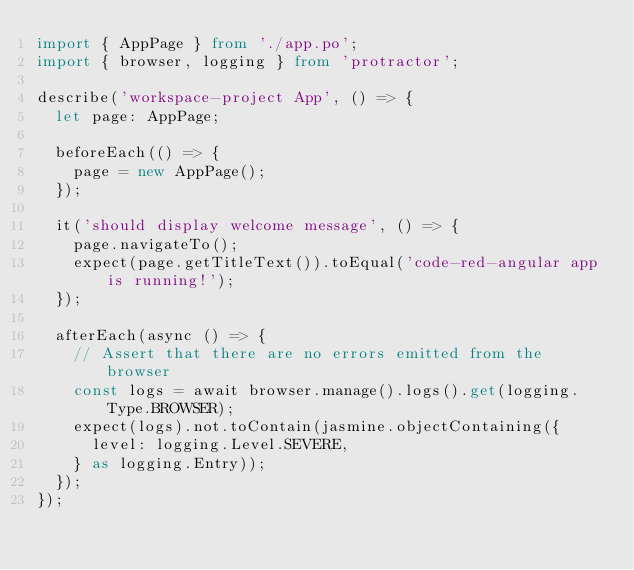Convert code to text. <code><loc_0><loc_0><loc_500><loc_500><_TypeScript_>import { AppPage } from './app.po';
import { browser, logging } from 'protractor';

describe('workspace-project App', () => {
  let page: AppPage;

  beforeEach(() => {
    page = new AppPage();
  });

  it('should display welcome message', () => {
    page.navigateTo();
    expect(page.getTitleText()).toEqual('code-red-angular app is running!');
  });

  afterEach(async () => {
    // Assert that there are no errors emitted from the browser
    const logs = await browser.manage().logs().get(logging.Type.BROWSER);
    expect(logs).not.toContain(jasmine.objectContaining({
      level: logging.Level.SEVERE,
    } as logging.Entry));
  });
});
</code> 